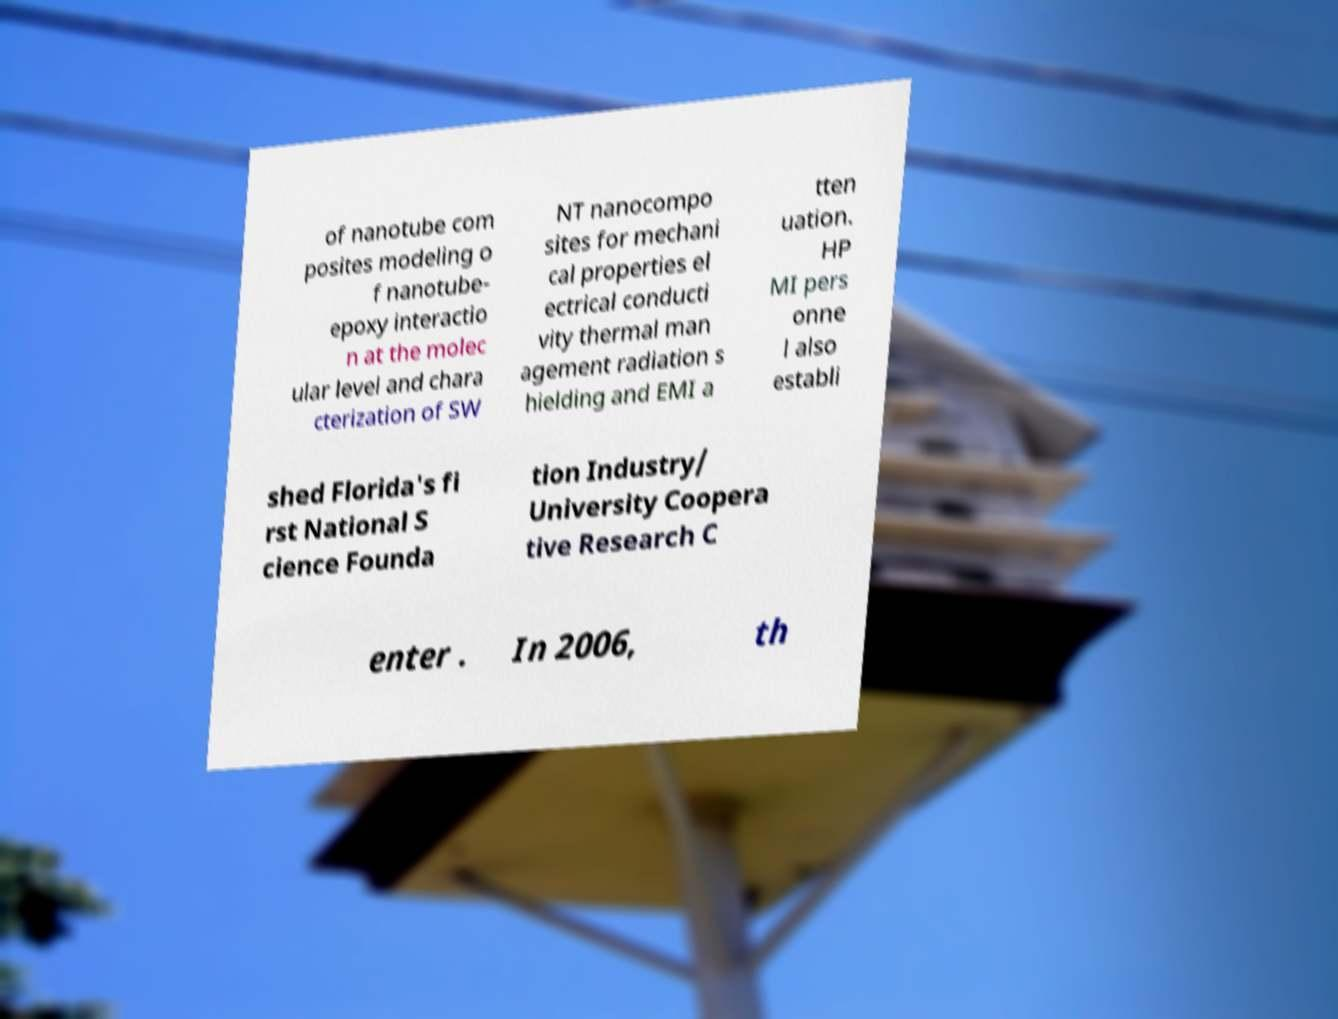There's text embedded in this image that I need extracted. Can you transcribe it verbatim? of nanotube com posites modeling o f nanotube- epoxy interactio n at the molec ular level and chara cterization of SW NT nanocompo sites for mechani cal properties el ectrical conducti vity thermal man agement radiation s hielding and EMI a tten uation. HP MI pers onne l also establi shed Florida's fi rst National S cience Founda tion Industry/ University Coopera tive Research C enter . In 2006, th 